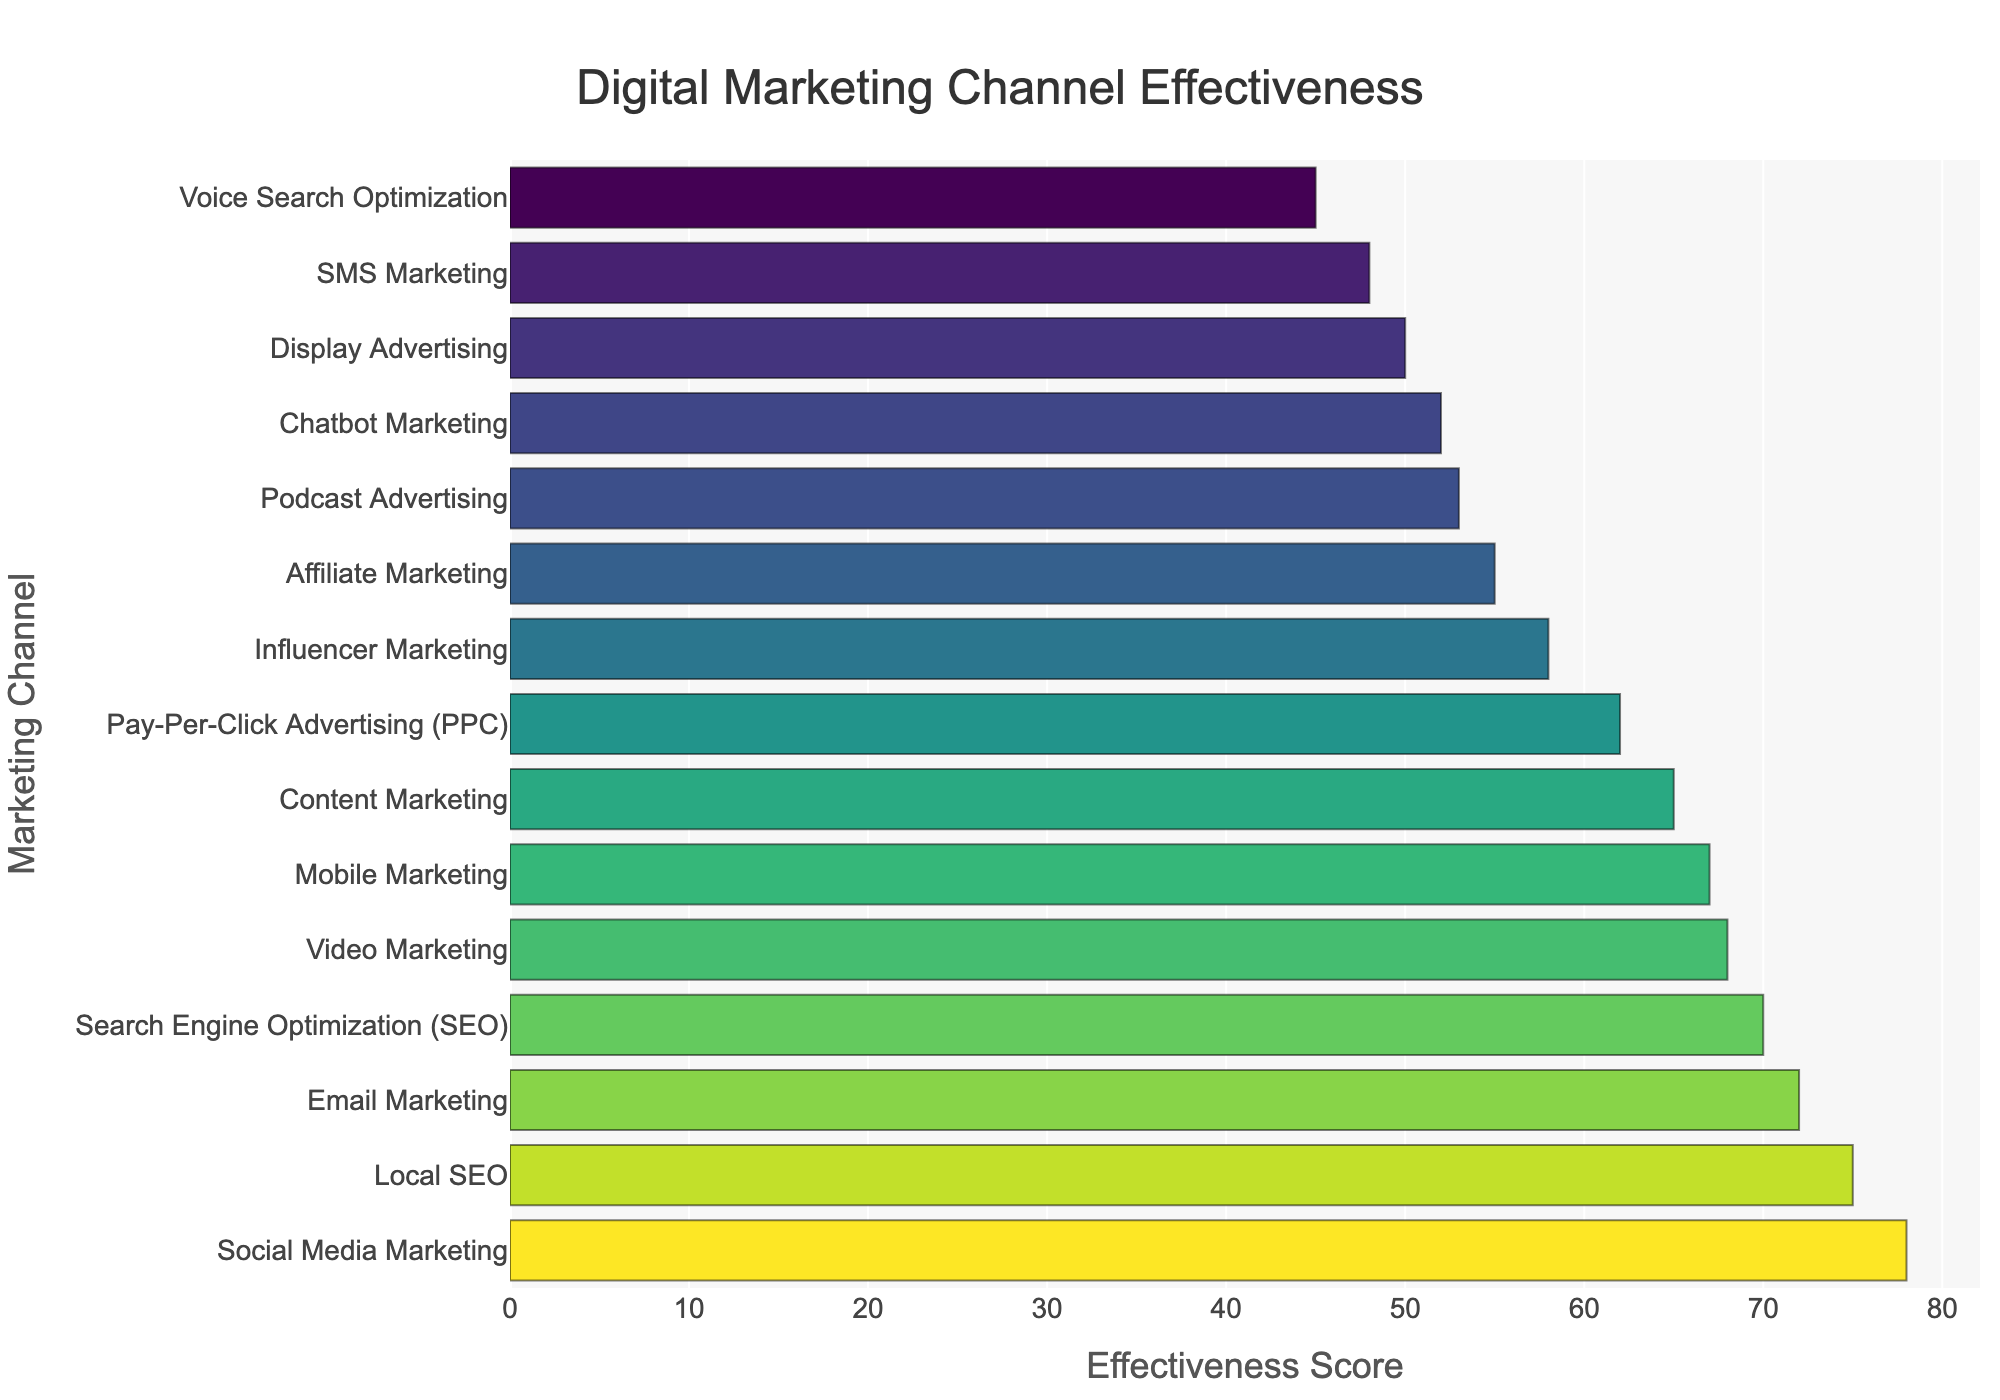Which digital marketing channel has the highest effectiveness score? The chart indicates that Social Media Marketing has the highest effectiveness score of all the channels.
Answer: Social Media Marketing Which digital marketing channel is more effective: SEO or Pay-Per-Click Advertising? By examining the bars, Search Engine Optimization (SEO) has an effectiveness score of 70, while Pay-Per-Click Advertising (PPC) has a score of 62. Thus, SEO is more effective.
Answer: SEO How does Email Marketing's effectiveness compare to Social Media Marketing? The effectiveness score of Email Marketing is 72, whereas Social Media Marketing has a score of 78. Therefore, Social Media Marketing is more effective.
Answer: Social Media Marketing is more effective What is the combined effectiveness score of Video Marketing and Mobile Marketing? According to the chart, Video Marketing has a score of 68 and Mobile Marketing has a score of 67. Their combined score is 68 + 67 = 135.
Answer: 135 Which marketing channels have an effectiveness score above 70? By inspecting the chart, Social Media Marketing (78), Email Marketing (72), Local SEO (75) have effectiveness scores above 70.
Answer: Social Media Marketing, Email Marketing, Local SEO What is the difference in effectiveness scores between Influencer Marketing and Podcast Advertising? Influencer Marketing has an effectiveness score of 58, while Podcast Advertising has a score of 53. The difference is 58 - 53 = 5.
Answer: 5 Which channel has the lowest effectiveness score? The lowest bar on the chart represents Voice Search Optimization, with an effectiveness score of 45.
Answer: Voice Search Optimization Among Local SEO, Content Marketing, and Affiliate Marketing, which is the most effective? By comparing the scores, Local SEO has a score of 75, Content Marketing has 65, and Affiliate Marketing has 55. Local SEO is the most effective among the three.
Answer: Local SEO Is the effectiveness score of Chatbot Marketing higher or lower than SMS Marketing? The effectiveness score of Chatbot Marketing is 52, while SMS Marketing has an effectiveness score of 48. Chatbot Marketing is higher.
Answer: Chatbot Marketing is higher What are the top three digital marketing channels in terms of effectiveness? The top three channels by effectiveness scores are Social Media Marketing (78), Local SEO (75), and Email Marketing (72).
Answer: Social Media Marketing, Local SEO, Email Marketing 